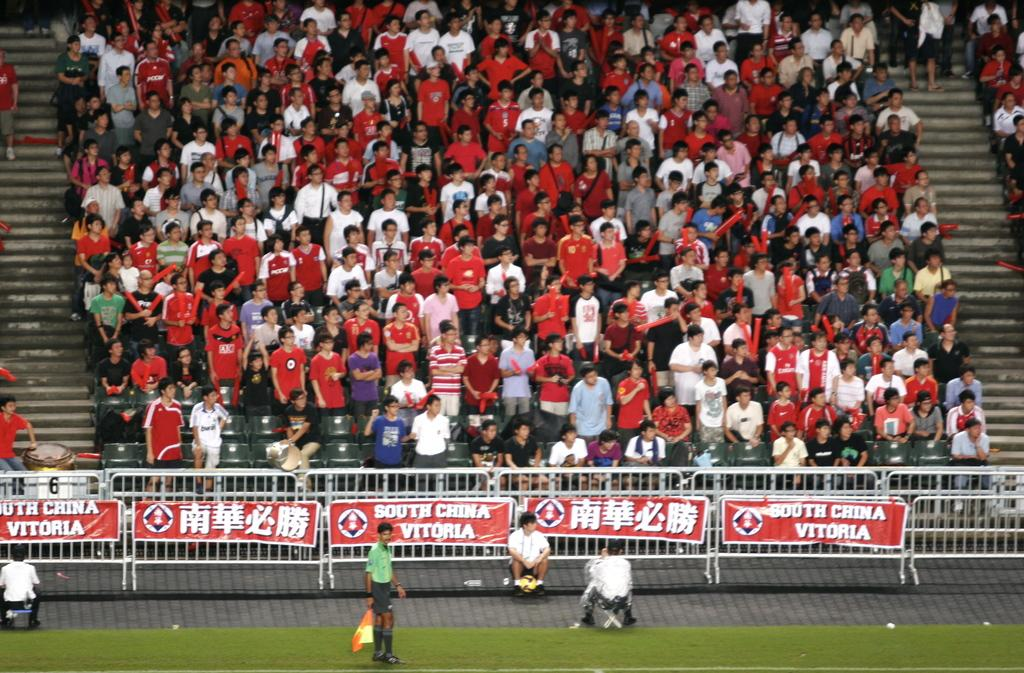<image>
Write a terse but informative summary of the picture. People sit in a grandstand at a South China vitoria match. 